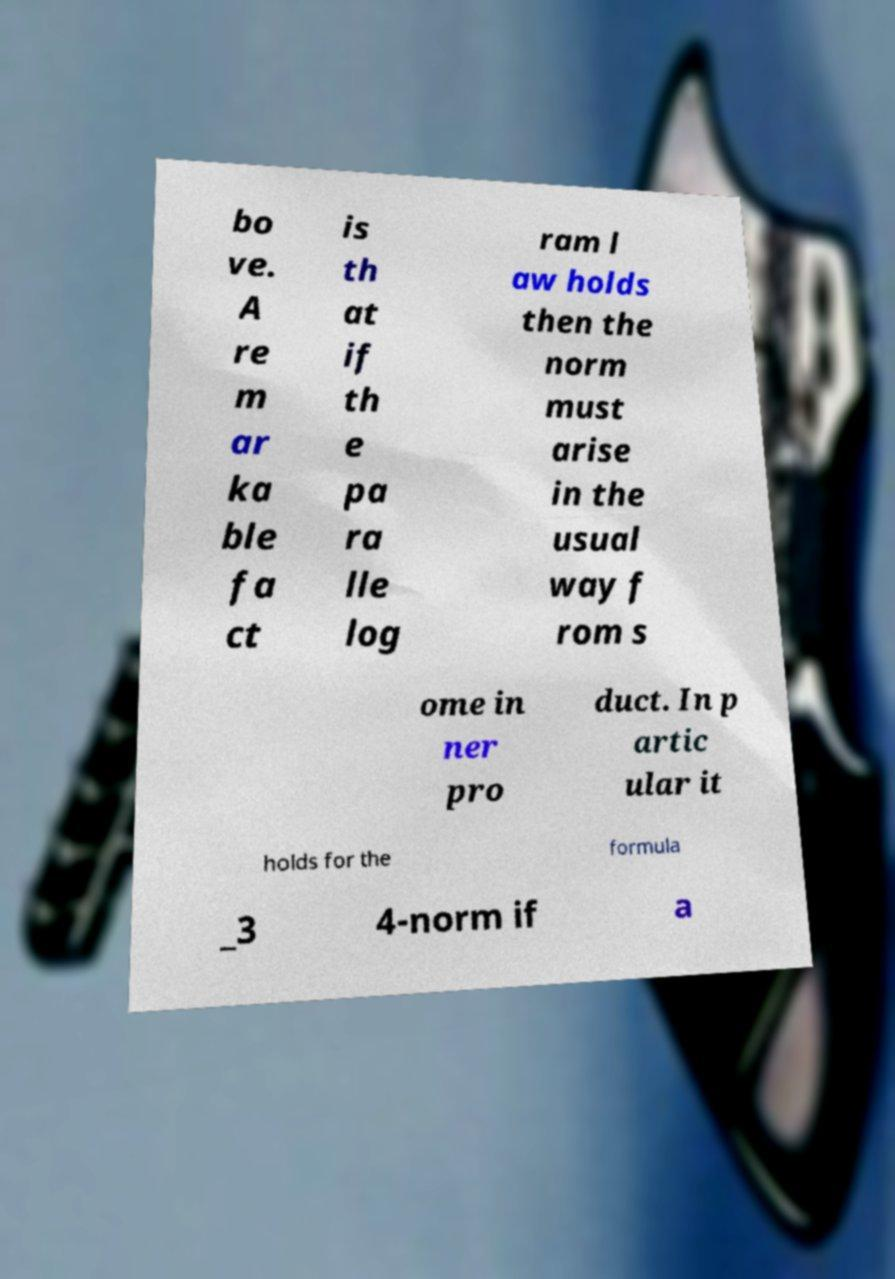There's text embedded in this image that I need extracted. Can you transcribe it verbatim? bo ve. A re m ar ka ble fa ct is th at if th e pa ra lle log ram l aw holds then the norm must arise in the usual way f rom s ome in ner pro duct. In p artic ular it holds for the formula _3 4-norm if a 